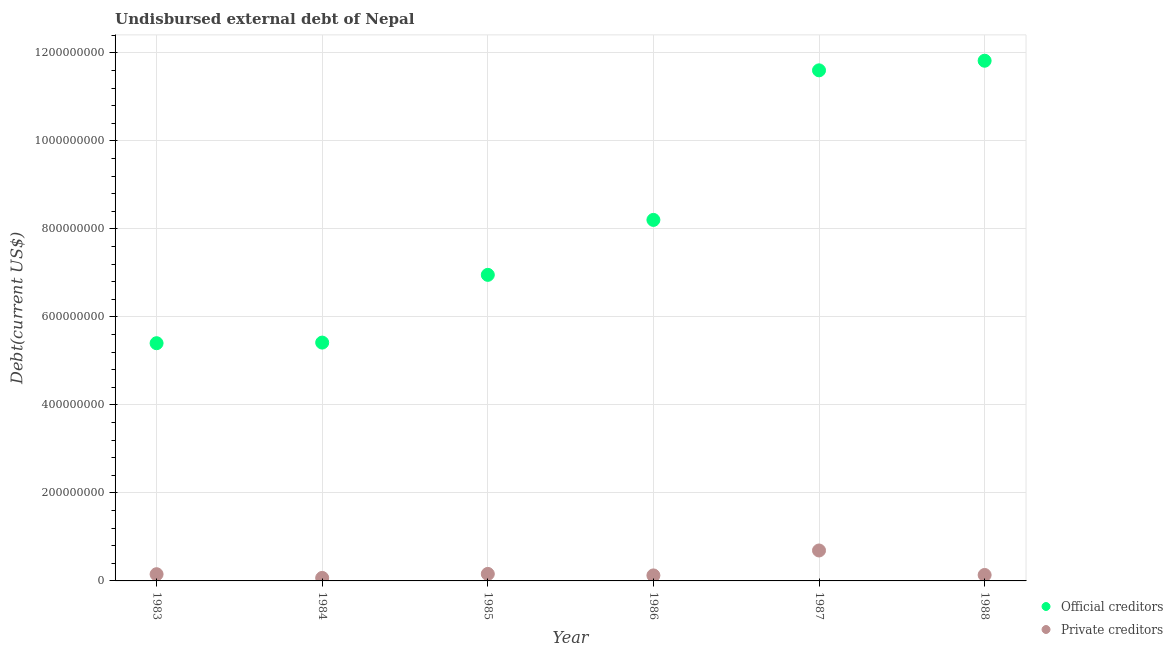How many different coloured dotlines are there?
Make the answer very short. 2. What is the undisbursed external debt of official creditors in 1988?
Your answer should be very brief. 1.18e+09. Across all years, what is the maximum undisbursed external debt of official creditors?
Offer a very short reply. 1.18e+09. Across all years, what is the minimum undisbursed external debt of private creditors?
Give a very brief answer. 6.82e+06. What is the total undisbursed external debt of official creditors in the graph?
Offer a very short reply. 4.94e+09. What is the difference between the undisbursed external debt of official creditors in 1986 and that in 1987?
Provide a short and direct response. -3.40e+08. What is the difference between the undisbursed external debt of private creditors in 1987 and the undisbursed external debt of official creditors in 1988?
Offer a very short reply. -1.11e+09. What is the average undisbursed external debt of private creditors per year?
Offer a very short reply. 2.22e+07. In the year 1986, what is the difference between the undisbursed external debt of official creditors and undisbursed external debt of private creditors?
Give a very brief answer. 8.08e+08. What is the ratio of the undisbursed external debt of official creditors in 1983 to that in 1987?
Offer a very short reply. 0.47. Is the difference between the undisbursed external debt of official creditors in 1983 and 1987 greater than the difference between the undisbursed external debt of private creditors in 1983 and 1987?
Your response must be concise. No. What is the difference between the highest and the second highest undisbursed external debt of private creditors?
Your answer should be very brief. 5.33e+07. What is the difference between the highest and the lowest undisbursed external debt of official creditors?
Give a very brief answer. 6.42e+08. Is the undisbursed external debt of official creditors strictly greater than the undisbursed external debt of private creditors over the years?
Your answer should be very brief. Yes. How many dotlines are there?
Make the answer very short. 2. How many years are there in the graph?
Make the answer very short. 6. What is the difference between two consecutive major ticks on the Y-axis?
Your answer should be compact. 2.00e+08. Does the graph contain any zero values?
Your answer should be compact. No. Where does the legend appear in the graph?
Your answer should be compact. Bottom right. How many legend labels are there?
Offer a very short reply. 2. What is the title of the graph?
Keep it short and to the point. Undisbursed external debt of Nepal. Does "Sanitation services" appear as one of the legend labels in the graph?
Provide a short and direct response. No. What is the label or title of the Y-axis?
Your answer should be very brief. Debt(current US$). What is the Debt(current US$) of Official creditors in 1983?
Keep it short and to the point. 5.40e+08. What is the Debt(current US$) of Private creditors in 1983?
Your answer should be very brief. 1.52e+07. What is the Debt(current US$) in Official creditors in 1984?
Make the answer very short. 5.42e+08. What is the Debt(current US$) in Private creditors in 1984?
Ensure brevity in your answer.  6.82e+06. What is the Debt(current US$) of Official creditors in 1985?
Provide a succinct answer. 6.95e+08. What is the Debt(current US$) in Private creditors in 1985?
Ensure brevity in your answer.  1.59e+07. What is the Debt(current US$) of Official creditors in 1986?
Give a very brief answer. 8.20e+08. What is the Debt(current US$) of Private creditors in 1986?
Provide a succinct answer. 1.25e+07. What is the Debt(current US$) of Official creditors in 1987?
Keep it short and to the point. 1.16e+09. What is the Debt(current US$) in Private creditors in 1987?
Your answer should be compact. 6.92e+07. What is the Debt(current US$) in Official creditors in 1988?
Make the answer very short. 1.18e+09. What is the Debt(current US$) in Private creditors in 1988?
Provide a succinct answer. 1.35e+07. Across all years, what is the maximum Debt(current US$) of Official creditors?
Make the answer very short. 1.18e+09. Across all years, what is the maximum Debt(current US$) of Private creditors?
Your answer should be compact. 6.92e+07. Across all years, what is the minimum Debt(current US$) of Official creditors?
Your answer should be very brief. 5.40e+08. Across all years, what is the minimum Debt(current US$) of Private creditors?
Offer a very short reply. 6.82e+06. What is the total Debt(current US$) of Official creditors in the graph?
Offer a terse response. 4.94e+09. What is the total Debt(current US$) of Private creditors in the graph?
Your response must be concise. 1.33e+08. What is the difference between the Debt(current US$) of Official creditors in 1983 and that in 1984?
Provide a succinct answer. -1.39e+06. What is the difference between the Debt(current US$) in Private creditors in 1983 and that in 1984?
Your answer should be very brief. 8.42e+06. What is the difference between the Debt(current US$) in Official creditors in 1983 and that in 1985?
Provide a short and direct response. -1.55e+08. What is the difference between the Debt(current US$) in Private creditors in 1983 and that in 1985?
Keep it short and to the point. -6.63e+05. What is the difference between the Debt(current US$) in Official creditors in 1983 and that in 1986?
Offer a very short reply. -2.80e+08. What is the difference between the Debt(current US$) of Private creditors in 1983 and that in 1986?
Offer a terse response. 2.74e+06. What is the difference between the Debt(current US$) of Official creditors in 1983 and that in 1987?
Give a very brief answer. -6.20e+08. What is the difference between the Debt(current US$) in Private creditors in 1983 and that in 1987?
Make the answer very short. -5.39e+07. What is the difference between the Debt(current US$) of Official creditors in 1983 and that in 1988?
Give a very brief answer. -6.42e+08. What is the difference between the Debt(current US$) of Private creditors in 1983 and that in 1988?
Offer a very short reply. 1.75e+06. What is the difference between the Debt(current US$) in Official creditors in 1984 and that in 1985?
Provide a short and direct response. -1.54e+08. What is the difference between the Debt(current US$) of Private creditors in 1984 and that in 1985?
Provide a short and direct response. -9.08e+06. What is the difference between the Debt(current US$) in Official creditors in 1984 and that in 1986?
Give a very brief answer. -2.79e+08. What is the difference between the Debt(current US$) in Private creditors in 1984 and that in 1986?
Offer a very short reply. -5.68e+06. What is the difference between the Debt(current US$) of Official creditors in 1984 and that in 1987?
Offer a very short reply. -6.19e+08. What is the difference between the Debt(current US$) in Private creditors in 1984 and that in 1987?
Make the answer very short. -6.23e+07. What is the difference between the Debt(current US$) in Official creditors in 1984 and that in 1988?
Offer a terse response. -6.40e+08. What is the difference between the Debt(current US$) of Private creditors in 1984 and that in 1988?
Provide a succinct answer. -6.67e+06. What is the difference between the Debt(current US$) in Official creditors in 1985 and that in 1986?
Give a very brief answer. -1.25e+08. What is the difference between the Debt(current US$) in Private creditors in 1985 and that in 1986?
Provide a succinct answer. 3.41e+06. What is the difference between the Debt(current US$) of Official creditors in 1985 and that in 1987?
Provide a succinct answer. -4.65e+08. What is the difference between the Debt(current US$) of Private creditors in 1985 and that in 1987?
Offer a terse response. -5.33e+07. What is the difference between the Debt(current US$) in Official creditors in 1985 and that in 1988?
Make the answer very short. -4.87e+08. What is the difference between the Debt(current US$) in Private creditors in 1985 and that in 1988?
Keep it short and to the point. 2.41e+06. What is the difference between the Debt(current US$) of Official creditors in 1986 and that in 1987?
Provide a short and direct response. -3.40e+08. What is the difference between the Debt(current US$) of Private creditors in 1986 and that in 1987?
Ensure brevity in your answer.  -5.67e+07. What is the difference between the Debt(current US$) of Official creditors in 1986 and that in 1988?
Make the answer very short. -3.62e+08. What is the difference between the Debt(current US$) in Private creditors in 1986 and that in 1988?
Make the answer very short. -9.94e+05. What is the difference between the Debt(current US$) of Official creditors in 1987 and that in 1988?
Your answer should be very brief. -2.18e+07. What is the difference between the Debt(current US$) in Private creditors in 1987 and that in 1988?
Ensure brevity in your answer.  5.57e+07. What is the difference between the Debt(current US$) of Official creditors in 1983 and the Debt(current US$) of Private creditors in 1984?
Your answer should be very brief. 5.33e+08. What is the difference between the Debt(current US$) in Official creditors in 1983 and the Debt(current US$) in Private creditors in 1985?
Provide a succinct answer. 5.24e+08. What is the difference between the Debt(current US$) in Official creditors in 1983 and the Debt(current US$) in Private creditors in 1986?
Ensure brevity in your answer.  5.28e+08. What is the difference between the Debt(current US$) of Official creditors in 1983 and the Debt(current US$) of Private creditors in 1987?
Your response must be concise. 4.71e+08. What is the difference between the Debt(current US$) in Official creditors in 1983 and the Debt(current US$) in Private creditors in 1988?
Provide a succinct answer. 5.27e+08. What is the difference between the Debt(current US$) of Official creditors in 1984 and the Debt(current US$) of Private creditors in 1985?
Make the answer very short. 5.26e+08. What is the difference between the Debt(current US$) of Official creditors in 1984 and the Debt(current US$) of Private creditors in 1986?
Your response must be concise. 5.29e+08. What is the difference between the Debt(current US$) of Official creditors in 1984 and the Debt(current US$) of Private creditors in 1987?
Provide a short and direct response. 4.72e+08. What is the difference between the Debt(current US$) of Official creditors in 1984 and the Debt(current US$) of Private creditors in 1988?
Provide a succinct answer. 5.28e+08. What is the difference between the Debt(current US$) in Official creditors in 1985 and the Debt(current US$) in Private creditors in 1986?
Ensure brevity in your answer.  6.83e+08. What is the difference between the Debt(current US$) in Official creditors in 1985 and the Debt(current US$) in Private creditors in 1987?
Keep it short and to the point. 6.26e+08. What is the difference between the Debt(current US$) of Official creditors in 1985 and the Debt(current US$) of Private creditors in 1988?
Provide a succinct answer. 6.82e+08. What is the difference between the Debt(current US$) of Official creditors in 1986 and the Debt(current US$) of Private creditors in 1987?
Your answer should be compact. 7.51e+08. What is the difference between the Debt(current US$) of Official creditors in 1986 and the Debt(current US$) of Private creditors in 1988?
Offer a very short reply. 8.07e+08. What is the difference between the Debt(current US$) of Official creditors in 1987 and the Debt(current US$) of Private creditors in 1988?
Provide a short and direct response. 1.15e+09. What is the average Debt(current US$) in Official creditors per year?
Provide a succinct answer. 8.23e+08. What is the average Debt(current US$) of Private creditors per year?
Offer a very short reply. 2.22e+07. In the year 1983, what is the difference between the Debt(current US$) in Official creditors and Debt(current US$) in Private creditors?
Your response must be concise. 5.25e+08. In the year 1984, what is the difference between the Debt(current US$) of Official creditors and Debt(current US$) of Private creditors?
Your response must be concise. 5.35e+08. In the year 1985, what is the difference between the Debt(current US$) in Official creditors and Debt(current US$) in Private creditors?
Make the answer very short. 6.80e+08. In the year 1986, what is the difference between the Debt(current US$) of Official creditors and Debt(current US$) of Private creditors?
Your response must be concise. 8.08e+08. In the year 1987, what is the difference between the Debt(current US$) in Official creditors and Debt(current US$) in Private creditors?
Your answer should be very brief. 1.09e+09. In the year 1988, what is the difference between the Debt(current US$) in Official creditors and Debt(current US$) in Private creditors?
Your answer should be very brief. 1.17e+09. What is the ratio of the Debt(current US$) of Private creditors in 1983 to that in 1984?
Your answer should be very brief. 2.23. What is the ratio of the Debt(current US$) in Official creditors in 1983 to that in 1985?
Ensure brevity in your answer.  0.78. What is the ratio of the Debt(current US$) in Official creditors in 1983 to that in 1986?
Make the answer very short. 0.66. What is the ratio of the Debt(current US$) in Private creditors in 1983 to that in 1986?
Make the answer very short. 1.22. What is the ratio of the Debt(current US$) in Official creditors in 1983 to that in 1987?
Your answer should be very brief. 0.47. What is the ratio of the Debt(current US$) in Private creditors in 1983 to that in 1987?
Your answer should be very brief. 0.22. What is the ratio of the Debt(current US$) in Official creditors in 1983 to that in 1988?
Make the answer very short. 0.46. What is the ratio of the Debt(current US$) of Private creditors in 1983 to that in 1988?
Your answer should be very brief. 1.13. What is the ratio of the Debt(current US$) of Official creditors in 1984 to that in 1985?
Keep it short and to the point. 0.78. What is the ratio of the Debt(current US$) of Private creditors in 1984 to that in 1985?
Your response must be concise. 0.43. What is the ratio of the Debt(current US$) of Official creditors in 1984 to that in 1986?
Ensure brevity in your answer.  0.66. What is the ratio of the Debt(current US$) of Private creditors in 1984 to that in 1986?
Give a very brief answer. 0.55. What is the ratio of the Debt(current US$) of Official creditors in 1984 to that in 1987?
Give a very brief answer. 0.47. What is the ratio of the Debt(current US$) of Private creditors in 1984 to that in 1987?
Your response must be concise. 0.1. What is the ratio of the Debt(current US$) in Official creditors in 1984 to that in 1988?
Offer a very short reply. 0.46. What is the ratio of the Debt(current US$) in Private creditors in 1984 to that in 1988?
Ensure brevity in your answer.  0.51. What is the ratio of the Debt(current US$) of Official creditors in 1985 to that in 1986?
Keep it short and to the point. 0.85. What is the ratio of the Debt(current US$) of Private creditors in 1985 to that in 1986?
Your answer should be very brief. 1.27. What is the ratio of the Debt(current US$) of Official creditors in 1985 to that in 1987?
Your answer should be compact. 0.6. What is the ratio of the Debt(current US$) of Private creditors in 1985 to that in 1987?
Provide a succinct answer. 0.23. What is the ratio of the Debt(current US$) in Official creditors in 1985 to that in 1988?
Your response must be concise. 0.59. What is the ratio of the Debt(current US$) of Private creditors in 1985 to that in 1988?
Your answer should be compact. 1.18. What is the ratio of the Debt(current US$) of Official creditors in 1986 to that in 1987?
Keep it short and to the point. 0.71. What is the ratio of the Debt(current US$) in Private creditors in 1986 to that in 1987?
Your answer should be compact. 0.18. What is the ratio of the Debt(current US$) of Official creditors in 1986 to that in 1988?
Provide a short and direct response. 0.69. What is the ratio of the Debt(current US$) in Private creditors in 1986 to that in 1988?
Provide a succinct answer. 0.93. What is the ratio of the Debt(current US$) of Official creditors in 1987 to that in 1988?
Ensure brevity in your answer.  0.98. What is the ratio of the Debt(current US$) in Private creditors in 1987 to that in 1988?
Your answer should be very brief. 5.13. What is the difference between the highest and the second highest Debt(current US$) of Official creditors?
Provide a short and direct response. 2.18e+07. What is the difference between the highest and the second highest Debt(current US$) of Private creditors?
Your answer should be very brief. 5.33e+07. What is the difference between the highest and the lowest Debt(current US$) in Official creditors?
Give a very brief answer. 6.42e+08. What is the difference between the highest and the lowest Debt(current US$) of Private creditors?
Give a very brief answer. 6.23e+07. 